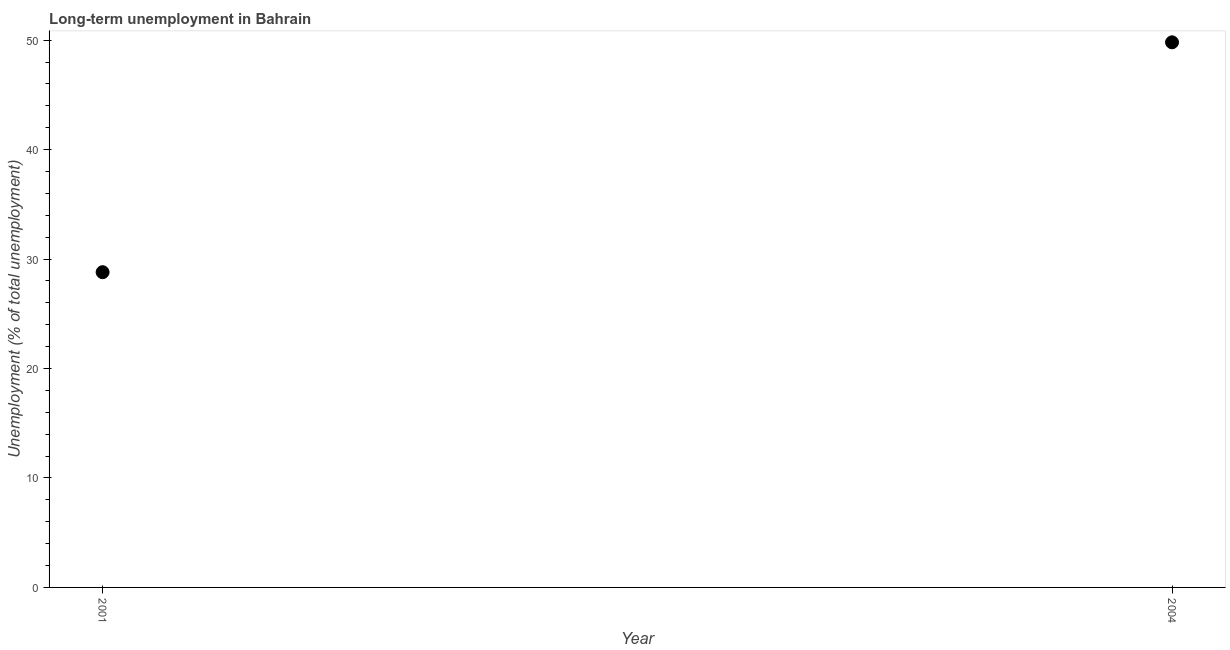What is the long-term unemployment in 2001?
Provide a succinct answer. 28.8. Across all years, what is the maximum long-term unemployment?
Give a very brief answer. 49.8. Across all years, what is the minimum long-term unemployment?
Make the answer very short. 28.8. In which year was the long-term unemployment minimum?
Keep it short and to the point. 2001. What is the sum of the long-term unemployment?
Keep it short and to the point. 78.6. What is the difference between the long-term unemployment in 2001 and 2004?
Your response must be concise. -21. What is the average long-term unemployment per year?
Provide a short and direct response. 39.3. What is the median long-term unemployment?
Provide a short and direct response. 39.3. What is the ratio of the long-term unemployment in 2001 to that in 2004?
Provide a succinct answer. 0.58. How many dotlines are there?
Your response must be concise. 1. How many years are there in the graph?
Give a very brief answer. 2. Does the graph contain grids?
Make the answer very short. No. What is the title of the graph?
Your response must be concise. Long-term unemployment in Bahrain. What is the label or title of the Y-axis?
Offer a very short reply. Unemployment (% of total unemployment). What is the Unemployment (% of total unemployment) in 2001?
Give a very brief answer. 28.8. What is the Unemployment (% of total unemployment) in 2004?
Offer a very short reply. 49.8. What is the ratio of the Unemployment (% of total unemployment) in 2001 to that in 2004?
Your response must be concise. 0.58. 